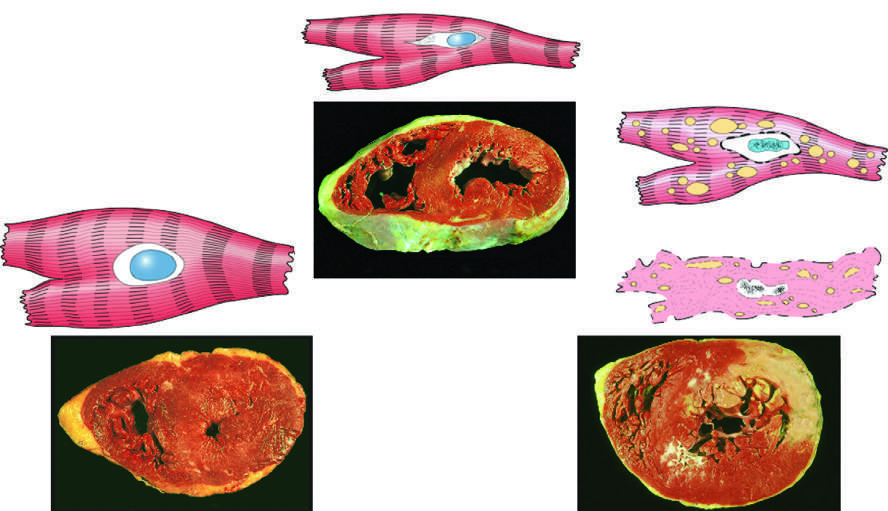s reversible injury thicker than 2 cm normal, 1-1.5 cm in the example of myocardial hypertrophy lower left?
Answer the question using a single word or phrase. No 